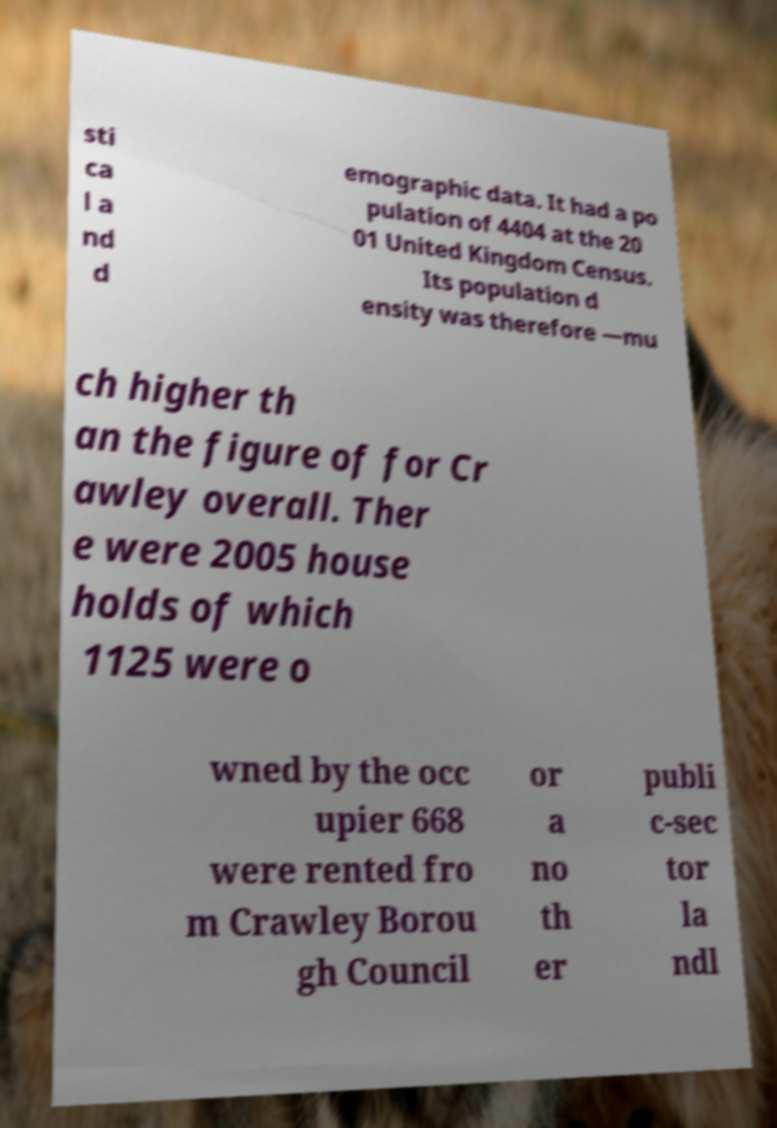There's text embedded in this image that I need extracted. Can you transcribe it verbatim? sti ca l a nd d emographic data. It had a po pulation of 4404 at the 20 01 United Kingdom Census. Its population d ensity was therefore —mu ch higher th an the figure of for Cr awley overall. Ther e were 2005 house holds of which 1125 were o wned by the occ upier 668 were rented fro m Crawley Borou gh Council or a no th er publi c-sec tor la ndl 